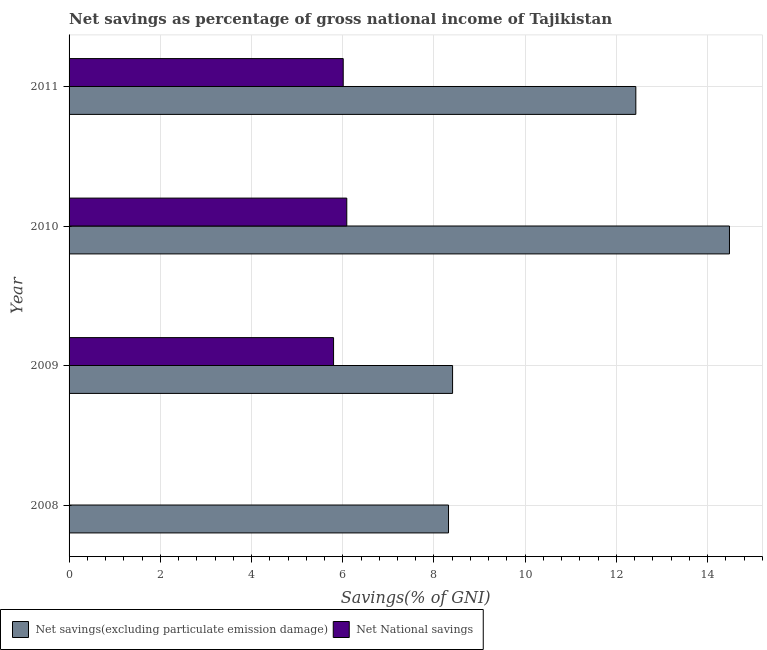How many different coloured bars are there?
Offer a very short reply. 2. Are the number of bars on each tick of the Y-axis equal?
Make the answer very short. No. What is the label of the 2nd group of bars from the top?
Offer a very short reply. 2010. In how many cases, is the number of bars for a given year not equal to the number of legend labels?
Your response must be concise. 1. What is the net national savings in 2009?
Provide a short and direct response. 5.8. Across all years, what is the maximum net national savings?
Your answer should be very brief. 6.09. Across all years, what is the minimum net savings(excluding particulate emission damage)?
Ensure brevity in your answer.  8.32. In which year was the net national savings maximum?
Give a very brief answer. 2010. What is the total net national savings in the graph?
Your response must be concise. 17.9. What is the difference between the net savings(excluding particulate emission damage) in 2008 and that in 2010?
Your answer should be compact. -6.16. What is the difference between the net savings(excluding particulate emission damage) in 2010 and the net national savings in 2011?
Offer a very short reply. 8.47. What is the average net national savings per year?
Keep it short and to the point. 4.47. In the year 2011, what is the difference between the net savings(excluding particulate emission damage) and net national savings?
Ensure brevity in your answer.  6.42. In how many years, is the net national savings greater than 14.8 %?
Provide a succinct answer. 0. What is the ratio of the net national savings in 2009 to that in 2010?
Provide a succinct answer. 0.95. What is the difference between the highest and the second highest net national savings?
Keep it short and to the point. 0.08. What is the difference between the highest and the lowest net savings(excluding particulate emission damage)?
Your answer should be very brief. 6.16. How many years are there in the graph?
Provide a short and direct response. 4. Are the values on the major ticks of X-axis written in scientific E-notation?
Your response must be concise. No. Where does the legend appear in the graph?
Offer a very short reply. Bottom left. How are the legend labels stacked?
Your response must be concise. Horizontal. What is the title of the graph?
Keep it short and to the point. Net savings as percentage of gross national income of Tajikistan. What is the label or title of the X-axis?
Offer a terse response. Savings(% of GNI). What is the label or title of the Y-axis?
Ensure brevity in your answer.  Year. What is the Savings(% of GNI) of Net savings(excluding particulate emission damage) in 2008?
Your answer should be compact. 8.32. What is the Savings(% of GNI) of Net savings(excluding particulate emission damage) in 2009?
Make the answer very short. 8.41. What is the Savings(% of GNI) of Net National savings in 2009?
Ensure brevity in your answer.  5.8. What is the Savings(% of GNI) of Net savings(excluding particulate emission damage) in 2010?
Ensure brevity in your answer.  14.48. What is the Savings(% of GNI) of Net National savings in 2010?
Your answer should be very brief. 6.09. What is the Savings(% of GNI) of Net savings(excluding particulate emission damage) in 2011?
Make the answer very short. 12.42. What is the Savings(% of GNI) in Net National savings in 2011?
Provide a short and direct response. 6.01. Across all years, what is the maximum Savings(% of GNI) of Net savings(excluding particulate emission damage)?
Offer a terse response. 14.48. Across all years, what is the maximum Savings(% of GNI) of Net National savings?
Offer a very short reply. 6.09. Across all years, what is the minimum Savings(% of GNI) of Net savings(excluding particulate emission damage)?
Offer a very short reply. 8.32. Across all years, what is the minimum Savings(% of GNI) in Net National savings?
Your answer should be compact. 0. What is the total Savings(% of GNI) of Net savings(excluding particulate emission damage) in the graph?
Make the answer very short. 43.63. What is the total Savings(% of GNI) in Net National savings in the graph?
Your answer should be compact. 17.9. What is the difference between the Savings(% of GNI) in Net savings(excluding particulate emission damage) in 2008 and that in 2009?
Provide a short and direct response. -0.09. What is the difference between the Savings(% of GNI) in Net savings(excluding particulate emission damage) in 2008 and that in 2010?
Offer a very short reply. -6.16. What is the difference between the Savings(% of GNI) of Net savings(excluding particulate emission damage) in 2008 and that in 2011?
Give a very brief answer. -4.11. What is the difference between the Savings(% of GNI) of Net savings(excluding particulate emission damage) in 2009 and that in 2010?
Your response must be concise. -6.07. What is the difference between the Savings(% of GNI) in Net National savings in 2009 and that in 2010?
Your answer should be very brief. -0.29. What is the difference between the Savings(% of GNI) in Net savings(excluding particulate emission damage) in 2009 and that in 2011?
Ensure brevity in your answer.  -4.02. What is the difference between the Savings(% of GNI) of Net National savings in 2009 and that in 2011?
Your answer should be compact. -0.21. What is the difference between the Savings(% of GNI) of Net savings(excluding particulate emission damage) in 2010 and that in 2011?
Offer a very short reply. 2.05. What is the difference between the Savings(% of GNI) of Net National savings in 2010 and that in 2011?
Offer a terse response. 0.08. What is the difference between the Savings(% of GNI) in Net savings(excluding particulate emission damage) in 2008 and the Savings(% of GNI) in Net National savings in 2009?
Your response must be concise. 2.52. What is the difference between the Savings(% of GNI) in Net savings(excluding particulate emission damage) in 2008 and the Savings(% of GNI) in Net National savings in 2010?
Your answer should be compact. 2.23. What is the difference between the Savings(% of GNI) of Net savings(excluding particulate emission damage) in 2008 and the Savings(% of GNI) of Net National savings in 2011?
Offer a very short reply. 2.31. What is the difference between the Savings(% of GNI) in Net savings(excluding particulate emission damage) in 2009 and the Savings(% of GNI) in Net National savings in 2010?
Your answer should be compact. 2.32. What is the difference between the Savings(% of GNI) of Net savings(excluding particulate emission damage) in 2009 and the Savings(% of GNI) of Net National savings in 2011?
Your answer should be compact. 2.4. What is the difference between the Savings(% of GNI) of Net savings(excluding particulate emission damage) in 2010 and the Savings(% of GNI) of Net National savings in 2011?
Your answer should be very brief. 8.47. What is the average Savings(% of GNI) in Net savings(excluding particulate emission damage) per year?
Your answer should be very brief. 10.91. What is the average Savings(% of GNI) in Net National savings per year?
Your response must be concise. 4.47. In the year 2009, what is the difference between the Savings(% of GNI) of Net savings(excluding particulate emission damage) and Savings(% of GNI) of Net National savings?
Make the answer very short. 2.61. In the year 2010, what is the difference between the Savings(% of GNI) of Net savings(excluding particulate emission damage) and Savings(% of GNI) of Net National savings?
Make the answer very short. 8.39. In the year 2011, what is the difference between the Savings(% of GNI) in Net savings(excluding particulate emission damage) and Savings(% of GNI) in Net National savings?
Your response must be concise. 6.41. What is the ratio of the Savings(% of GNI) of Net savings(excluding particulate emission damage) in 2008 to that in 2009?
Your response must be concise. 0.99. What is the ratio of the Savings(% of GNI) in Net savings(excluding particulate emission damage) in 2008 to that in 2010?
Provide a succinct answer. 0.57. What is the ratio of the Savings(% of GNI) in Net savings(excluding particulate emission damage) in 2008 to that in 2011?
Ensure brevity in your answer.  0.67. What is the ratio of the Savings(% of GNI) of Net savings(excluding particulate emission damage) in 2009 to that in 2010?
Your answer should be very brief. 0.58. What is the ratio of the Savings(% of GNI) of Net savings(excluding particulate emission damage) in 2009 to that in 2011?
Offer a very short reply. 0.68. What is the ratio of the Savings(% of GNI) of Net National savings in 2009 to that in 2011?
Make the answer very short. 0.96. What is the ratio of the Savings(% of GNI) in Net savings(excluding particulate emission damage) in 2010 to that in 2011?
Offer a very short reply. 1.17. What is the ratio of the Savings(% of GNI) of Net National savings in 2010 to that in 2011?
Provide a short and direct response. 1.01. What is the difference between the highest and the second highest Savings(% of GNI) in Net savings(excluding particulate emission damage)?
Provide a succinct answer. 2.05. What is the difference between the highest and the second highest Savings(% of GNI) of Net National savings?
Ensure brevity in your answer.  0.08. What is the difference between the highest and the lowest Savings(% of GNI) of Net savings(excluding particulate emission damage)?
Keep it short and to the point. 6.16. What is the difference between the highest and the lowest Savings(% of GNI) in Net National savings?
Provide a short and direct response. 6.09. 